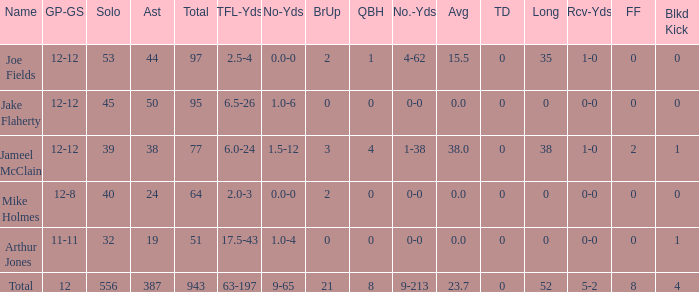How many yards does a player have if they have 2.5 tfl-yds and a loss of 4 yards? 4-62. 